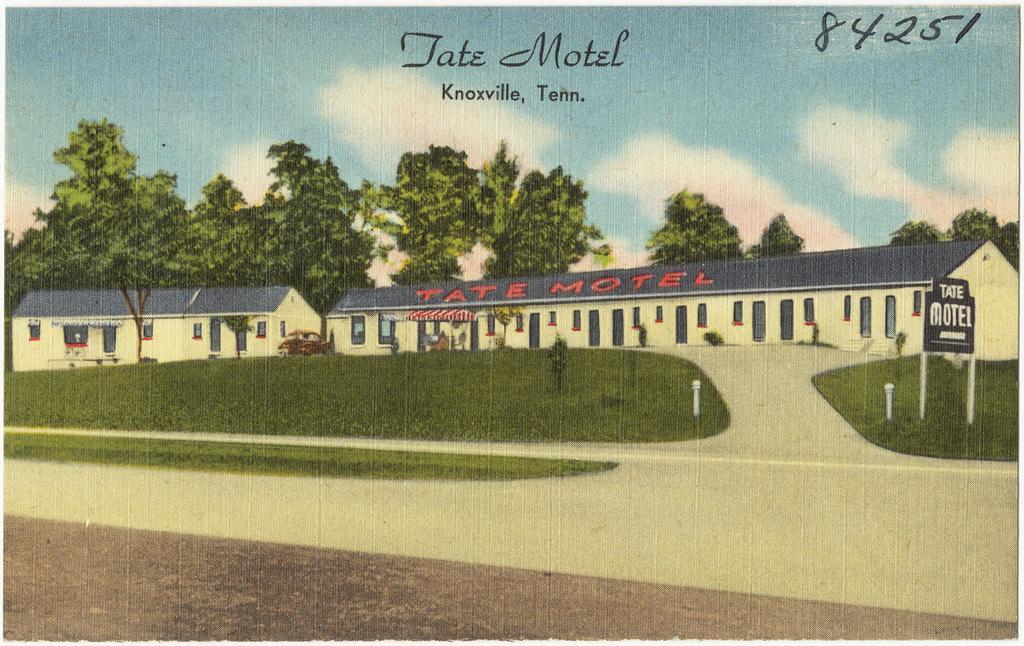In one or two sentences, can you explain what this image depicts? In this picture we can see hotels, grass, border, plants, vehicle and trees. Background there is a sky. These are clouds. Here we can see watermarks. 